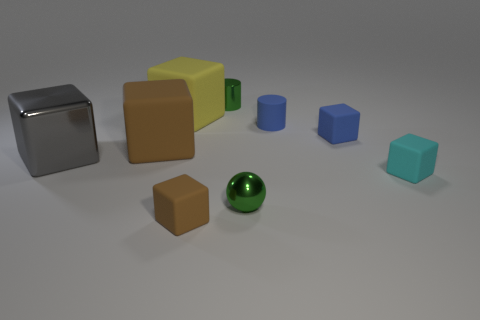What number of objects are large gray blocks that are to the left of the cyan rubber cube or tiny blue rubber objects?
Ensure brevity in your answer.  3. Are the block in front of the green metal sphere and the small green ball made of the same material?
Keep it short and to the point. No. Is the big yellow matte object the same shape as the gray thing?
Offer a very short reply. Yes. There is a yellow rubber block that is to the left of the tiny brown cube; how many big brown matte things are to the left of it?
Provide a succinct answer. 1. There is a small brown thing that is the same shape as the big metallic object; what is its material?
Provide a short and direct response. Rubber. There is a metal object that is to the right of the green metallic cylinder; does it have the same color as the tiny metallic cylinder?
Offer a terse response. Yes. Are the small brown object and the brown object that is behind the gray object made of the same material?
Provide a short and direct response. Yes. There is a shiny object on the left side of the small metal cylinder; what shape is it?
Provide a succinct answer. Cube. What number of other objects are the same material as the gray object?
Offer a very short reply. 2. The cyan matte block is what size?
Your answer should be very brief. Small. 